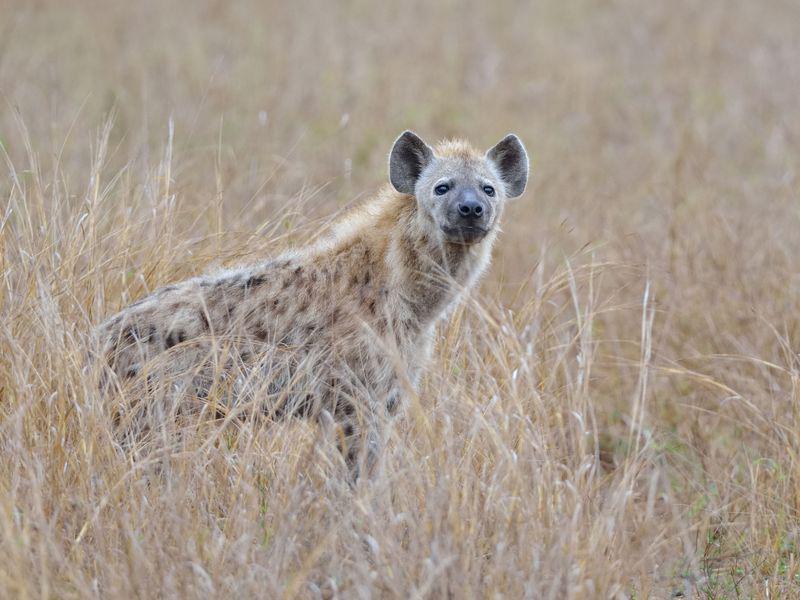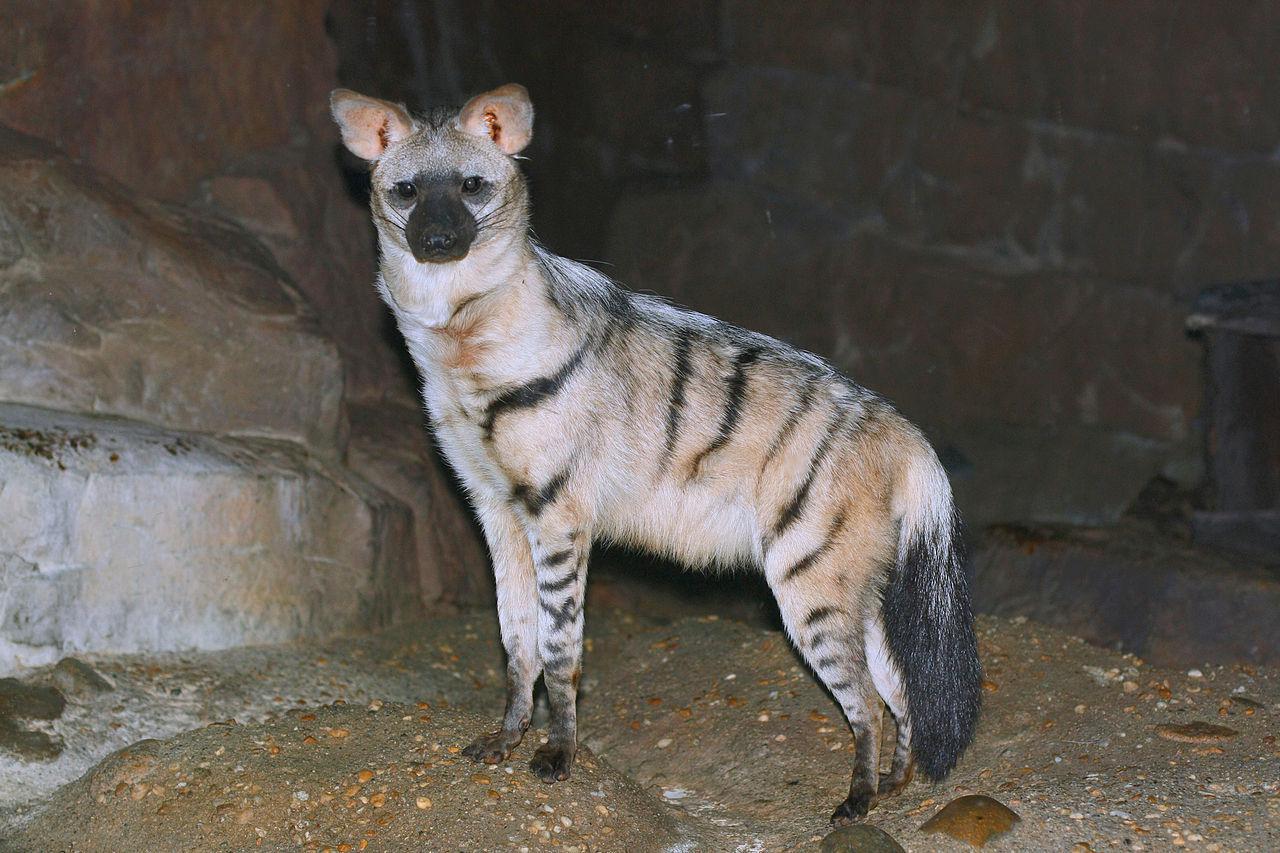The first image is the image on the left, the second image is the image on the right. Examine the images to the left and right. Is the description "There is at least one hyena laying on the ground." accurate? Answer yes or no. No. The first image is the image on the left, the second image is the image on the right. Assess this claim about the two images: "Two hyenas are visible.". Correct or not? Answer yes or no. Yes. 